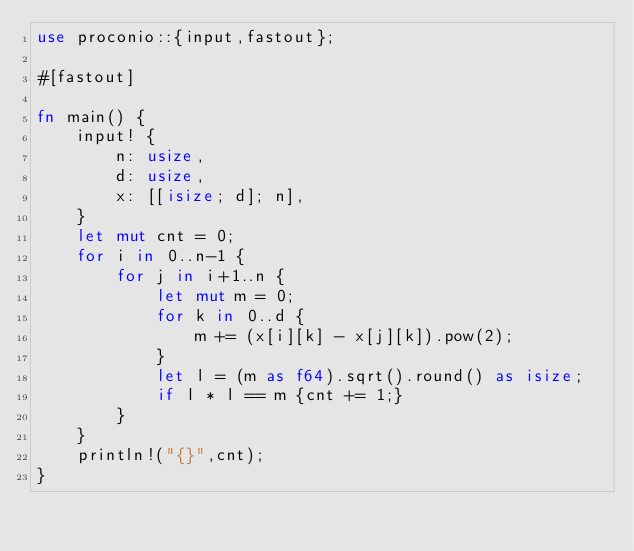Convert code to text. <code><loc_0><loc_0><loc_500><loc_500><_Rust_>use proconio::{input,fastout};

#[fastout]

fn main() {
    input! {
        n: usize,
        d: usize,
        x: [[isize; d]; n],
    }
    let mut cnt = 0;
    for i in 0..n-1 {
        for j in i+1..n {
            let mut m = 0;
            for k in 0..d {
                m += (x[i][k] - x[j][k]).pow(2);
            }
            let l = (m as f64).sqrt().round() as isize;
            if l * l == m {cnt += 1;}
        }
    }
    println!("{}",cnt);
}
</code> 